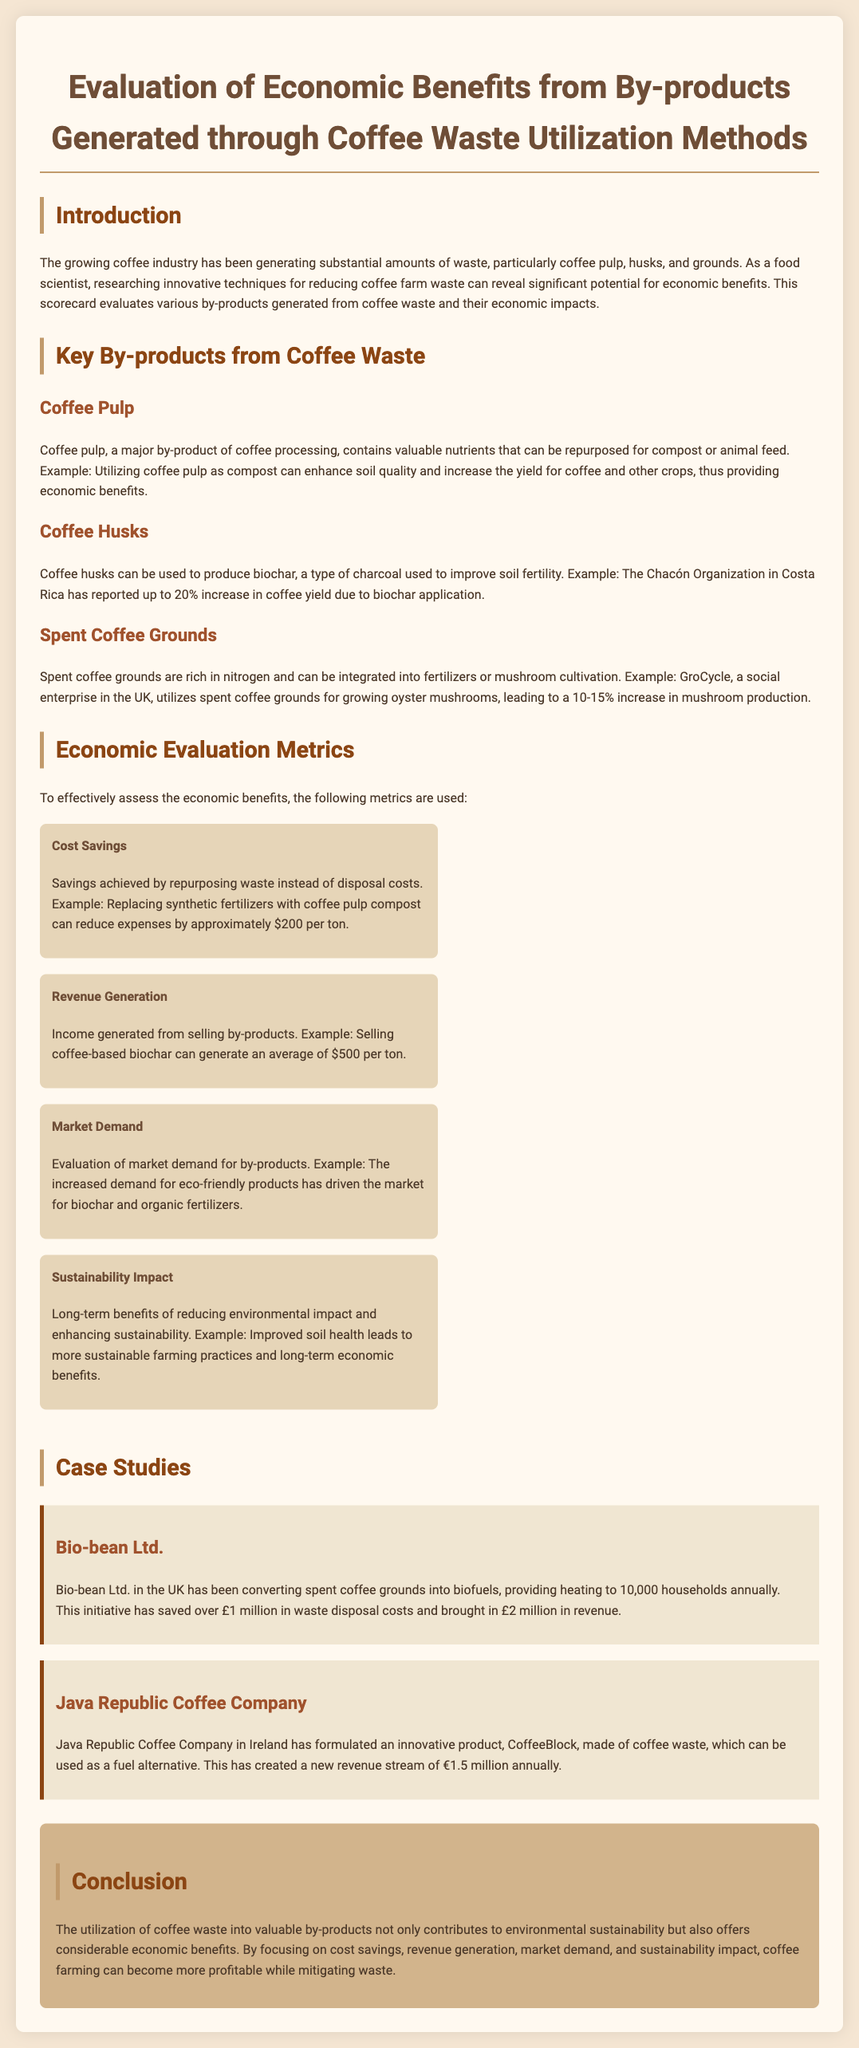what is the main by-product discussed for enhancing soil quality? The document mentions coffee pulp as a by-product that can enhance soil quality when used as compost.
Answer: coffee pulp how much can utilizing coffee pulp as compost reduce expenses? The document states that replacing synthetic fertilizers with coffee pulp compost can reduce expenses by approximately $200 per ton.
Answer: $200 what increase in coffee yield was reported by the Chacón Organization due to biochar application? The document reports a 20% increase in coffee yield due to biochar application by the Chacón Organization.
Answer: 20% what is the new revenue stream created by Java Republic Coffee Company? The document explains that Java Republic Coffee Company created a new revenue stream of €1.5 million annually from their product CoffeeBlock.
Answer: €1.5 million what are the four economic evaluation metrics used in the document? The document outlines four economic evaluation metrics: cost savings, revenue generation, market demand, and sustainability impact.
Answer: cost savings, revenue generation, market demand, sustainability impact how much revenue did Bio-bean Ltd. generate from converting spent coffee grounds into biofuels? The revenue generated by Bio-bean Ltd. from converting spent coffee grounds into biofuels is mentioned as £2 million.
Answer: £2 million what type of impacts does the sustainability impact metric evaluate? The sustainability impact metric evaluates long-term benefits of reducing environmental impact and enhancing sustainability.
Answer: long-term benefits what fuel alternative product did Java Republic Coffee Company create? The document states that Java Republic Coffee Company developed a product called CoffeeBlock, which is used as a fuel alternative.
Answer: CoffeeBlock 